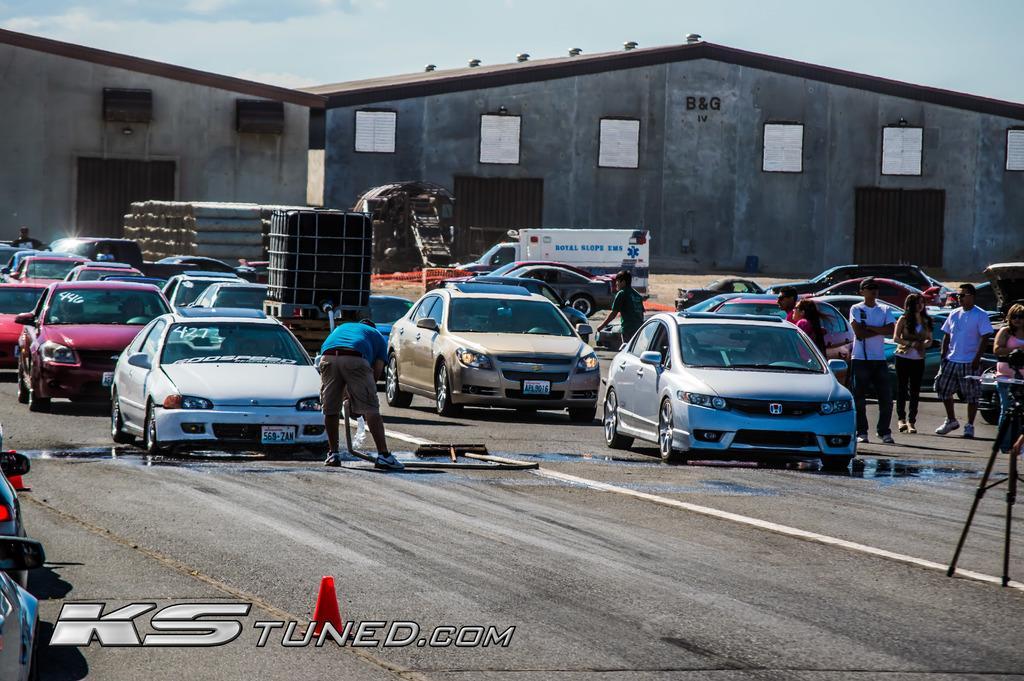Describe this image in one or two sentences. In this picture we can see vehicles, people, water, traffic cones and some objects on the road. Behind the vehicles, there are sheds and the sky. At the bottom of the image, there is a watermark. 